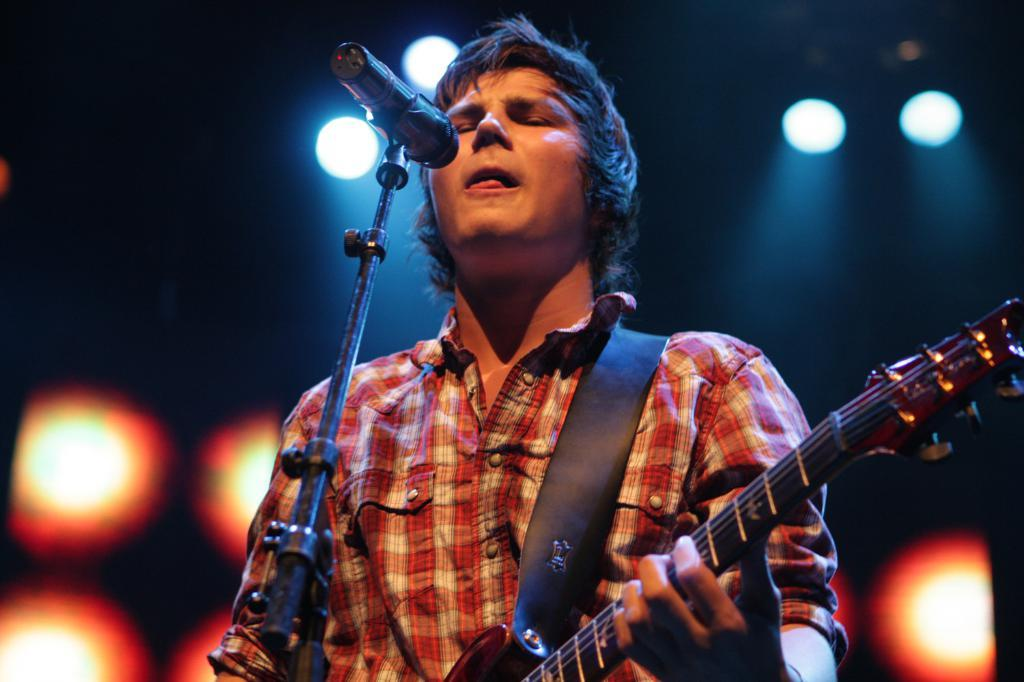Who or what is the main subject in the image? There is a person in the image. Where is the person located in the image? The person is in the center of the image. What is the person holding in the image? The person is holding a guitar. What type of clothing is the person wearing? The person is wearing a shirt. What object is in front of the person in the image? The person is standing in front of a microphone. What part of the world is the person pointing to on the map in the image? There is no map present in the image, so it is not possible to answer that question. 